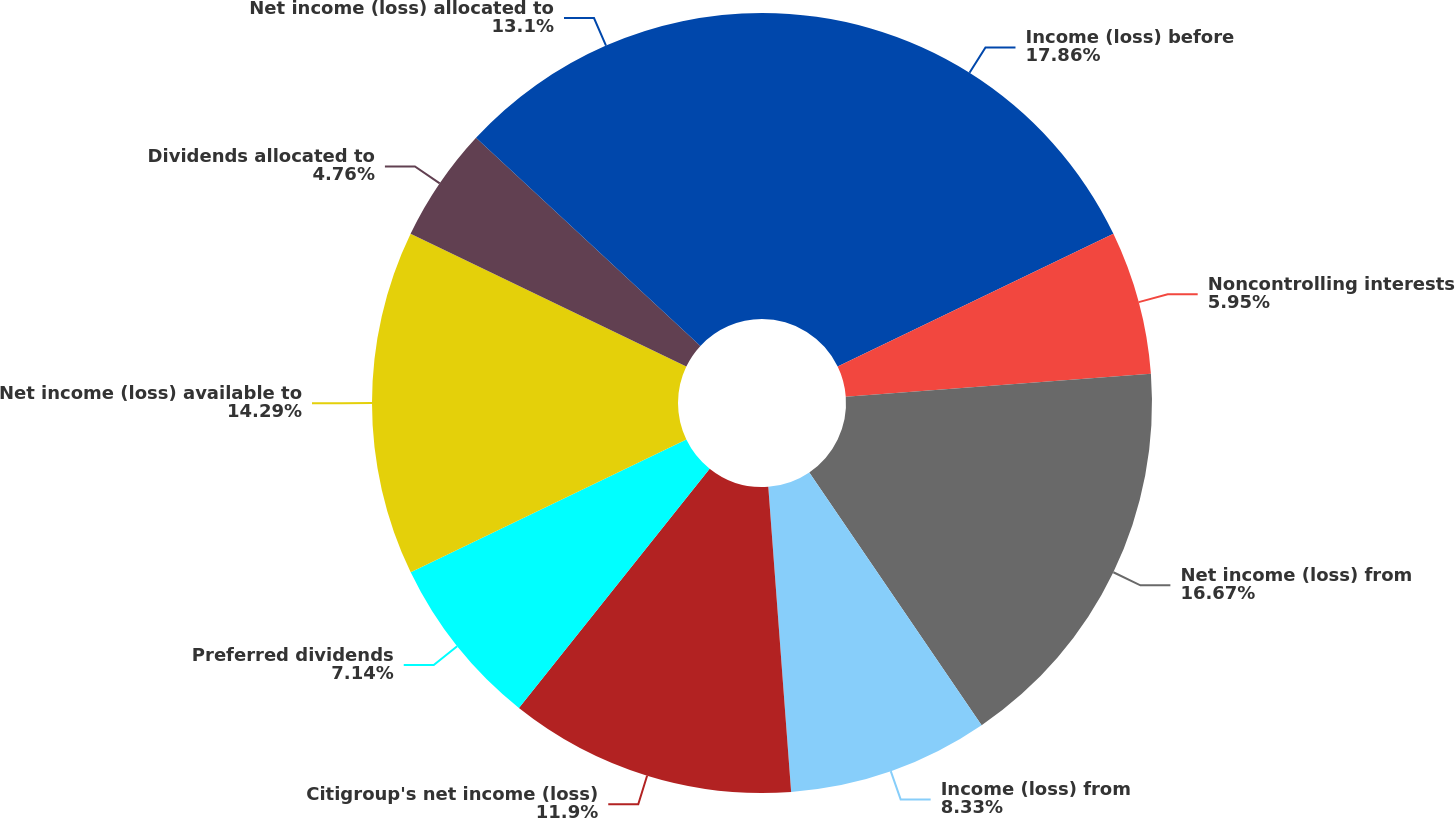<chart> <loc_0><loc_0><loc_500><loc_500><pie_chart><fcel>Income (loss) before<fcel>Noncontrolling interests<fcel>Net income (loss) from<fcel>Income (loss) from<fcel>Citigroup's net income (loss)<fcel>Preferred dividends<fcel>Net income (loss) available to<fcel>Dividends allocated to<fcel>Net income (loss) allocated to<nl><fcel>17.86%<fcel>5.95%<fcel>16.67%<fcel>8.33%<fcel>11.9%<fcel>7.14%<fcel>14.29%<fcel>4.76%<fcel>13.1%<nl></chart> 